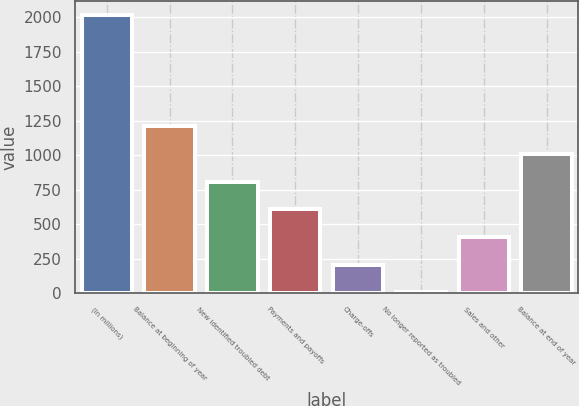Convert chart. <chart><loc_0><loc_0><loc_500><loc_500><bar_chart><fcel>(In millions)<fcel>Balance at beginning of year<fcel>New identified troubled debt<fcel>Payments and payoffs<fcel>Charge-offs<fcel>No longer reported as troubled<fcel>Sales and other<fcel>Balance at end of year<nl><fcel>2017<fcel>1211.8<fcel>809.2<fcel>607.9<fcel>205.3<fcel>4<fcel>406.6<fcel>1010.5<nl></chart> 